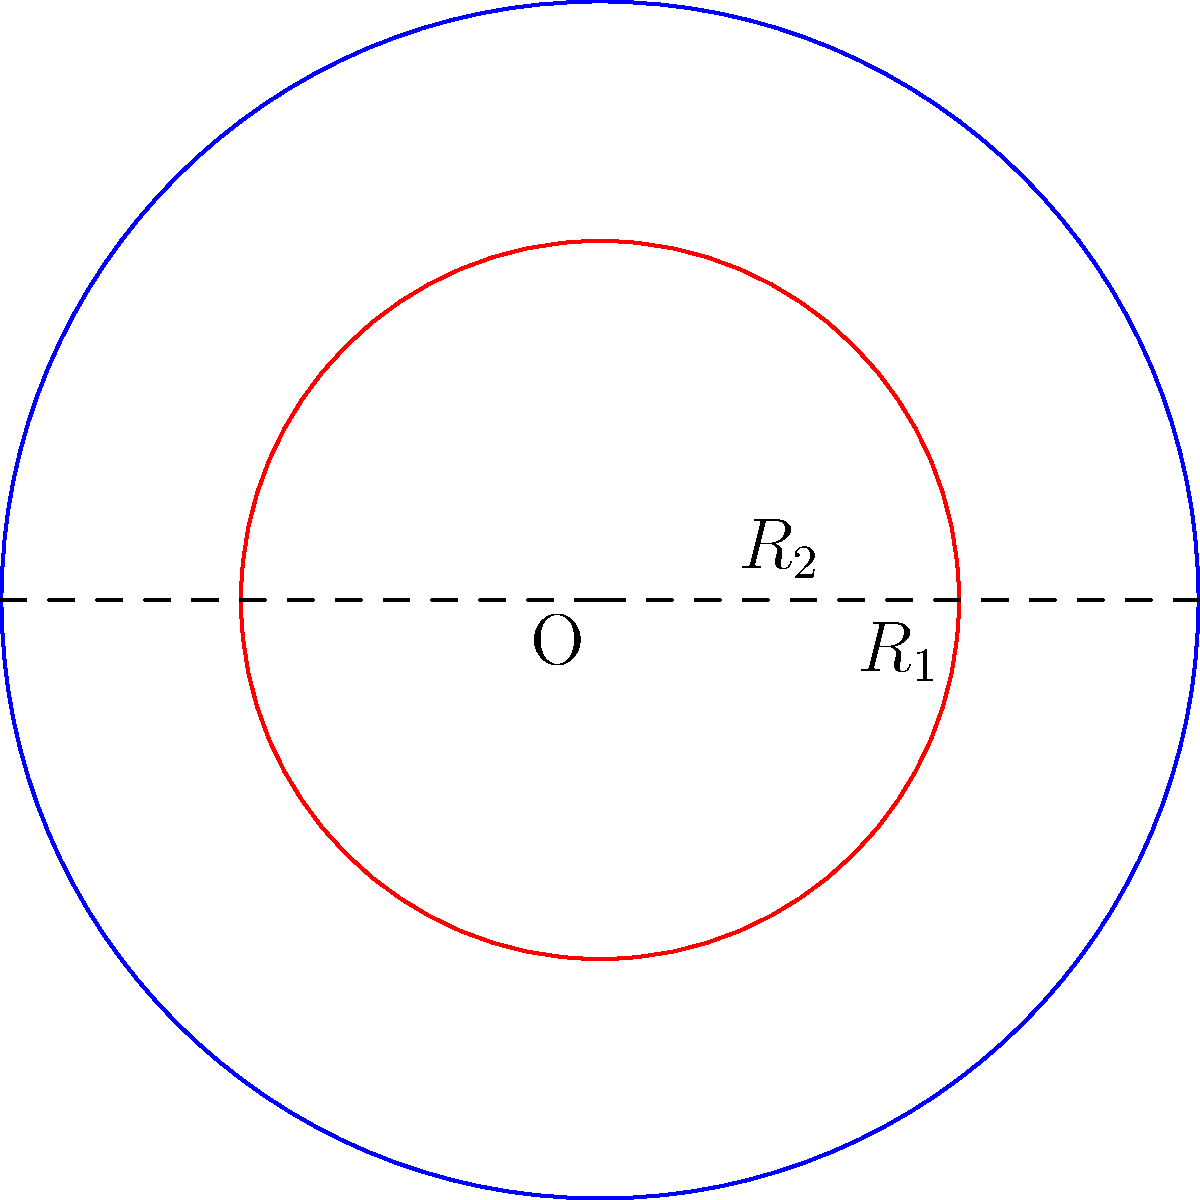Given two concentric circles with radii $R_1 = 5$ units and $R_2 = 3$ units, calculate the area of the region between these circles. How might this problem relate to analyzing the receptive fields of neurons in convolutional neural networks? To solve this problem, we'll follow these steps:

1) The area between two concentric circles is the difference between the areas of the larger and smaller circles.

2) The area of a circle is given by the formula $A = \pi r^2$, where $r$ is the radius.

3) For the larger circle (blue):
   $A_1 = \pi R_1^2 = \pi (5^2) = 25\pi$ square units

4) For the smaller circle (red):
   $A_2 = \pi R_2^2 = \pi (3^2) = 9\pi$ square units

5) The area between the circles is:
   $A_{between} = A_1 - A_2 = 25\pi - 9\pi = 16\pi$ square units

Relating to neural networks:
This problem is analogous to analyzing receptive fields in convolutional neural networks (CNNs). In CNNs, neurons in higher layers have larger receptive fields than those in lower layers. The area between concentric circles can represent the increase in the receptive field size as we move up the network hierarchy. Understanding these geometric relationships helps in designing effective CNN architectures and interpreting their behavior.
Answer: $16\pi$ square units 